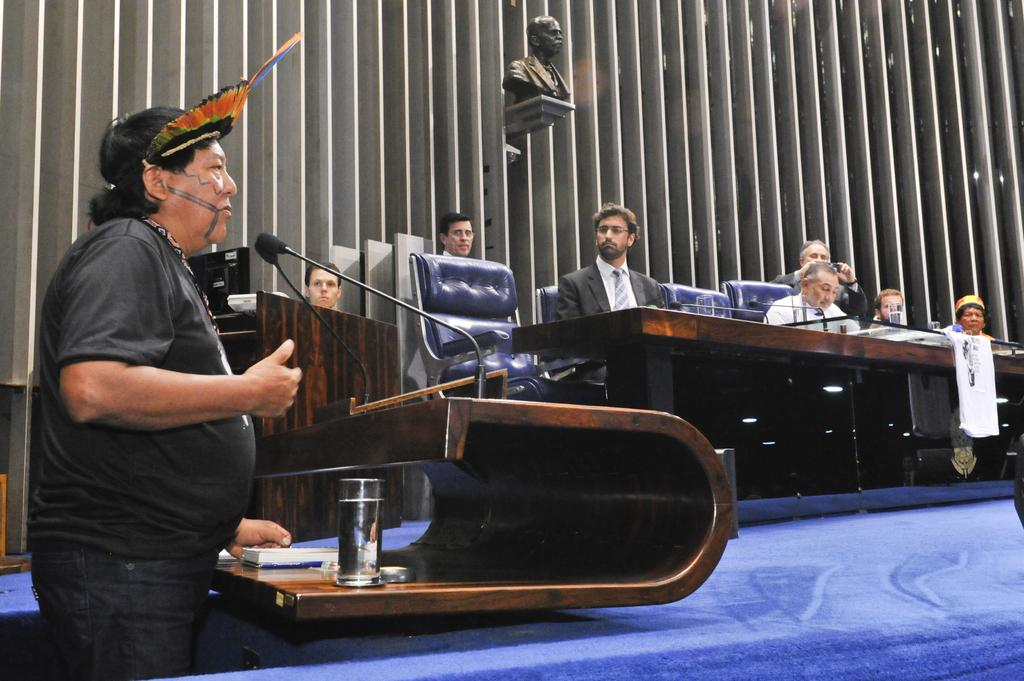What is the man doing in the image? The man is standing at a podium on the left side of the image. What are the people in the image doing? There are many people sitting on chairs in the image. Can you describe the statue in the image? There is a statue on a wall in the image. What type of tin can be seen near the statue in the image? There is no tin present in the image; it only features a man at a podium, people sitting on chairs, and a statue on a wall. 